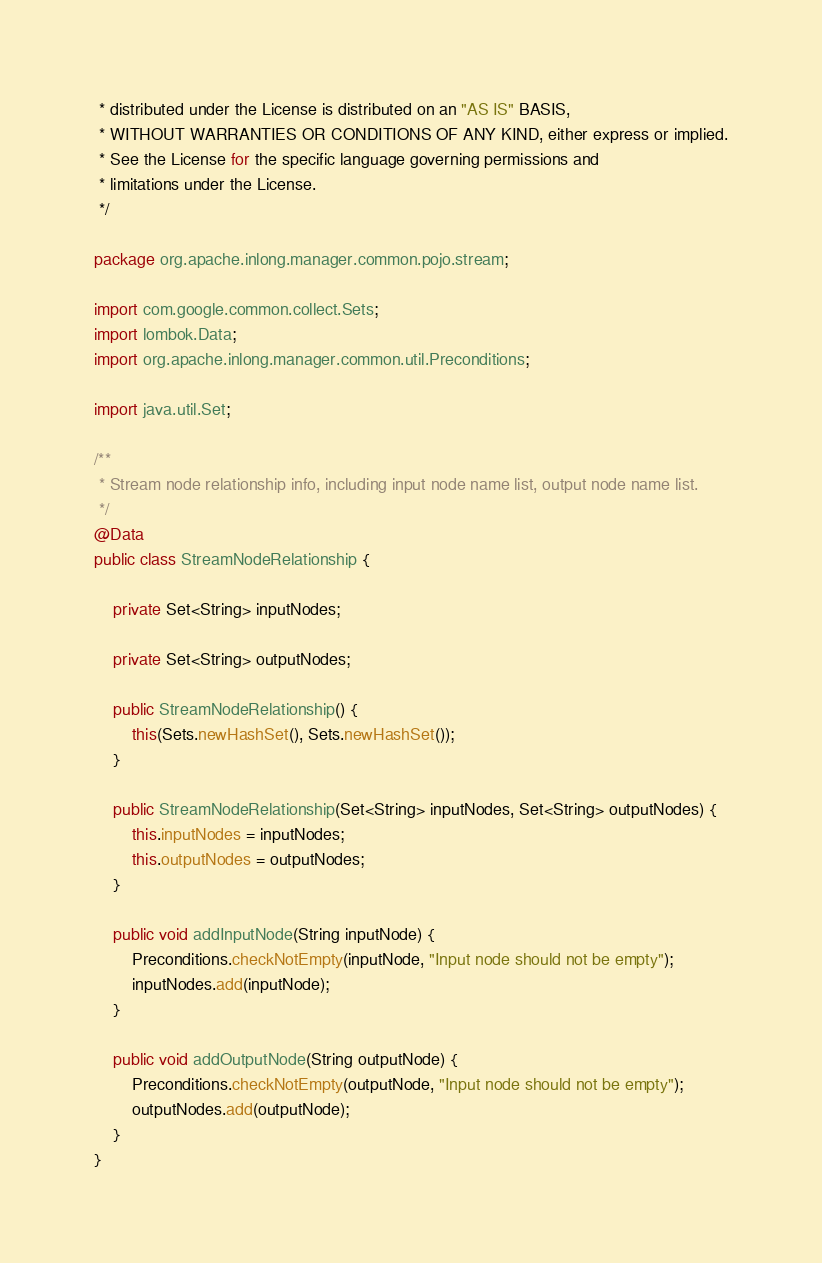<code> <loc_0><loc_0><loc_500><loc_500><_Java_> * distributed under the License is distributed on an "AS IS" BASIS,
 * WITHOUT WARRANTIES OR CONDITIONS OF ANY KIND, either express or implied.
 * See the License for the specific language governing permissions and
 * limitations under the License.
 */

package org.apache.inlong.manager.common.pojo.stream;

import com.google.common.collect.Sets;
import lombok.Data;
import org.apache.inlong.manager.common.util.Preconditions;

import java.util.Set;

/**
 * Stream node relationship info, including input node name list, output node name list.
 */
@Data
public class StreamNodeRelationship {

    private Set<String> inputNodes;

    private Set<String> outputNodes;

    public StreamNodeRelationship() {
        this(Sets.newHashSet(), Sets.newHashSet());
    }

    public StreamNodeRelationship(Set<String> inputNodes, Set<String> outputNodes) {
        this.inputNodes = inputNodes;
        this.outputNodes = outputNodes;
    }

    public void addInputNode(String inputNode) {
        Preconditions.checkNotEmpty(inputNode, "Input node should not be empty");
        inputNodes.add(inputNode);
    }

    public void addOutputNode(String outputNode) {
        Preconditions.checkNotEmpty(outputNode, "Input node should not be empty");
        outputNodes.add(outputNode);
    }
}
</code> 